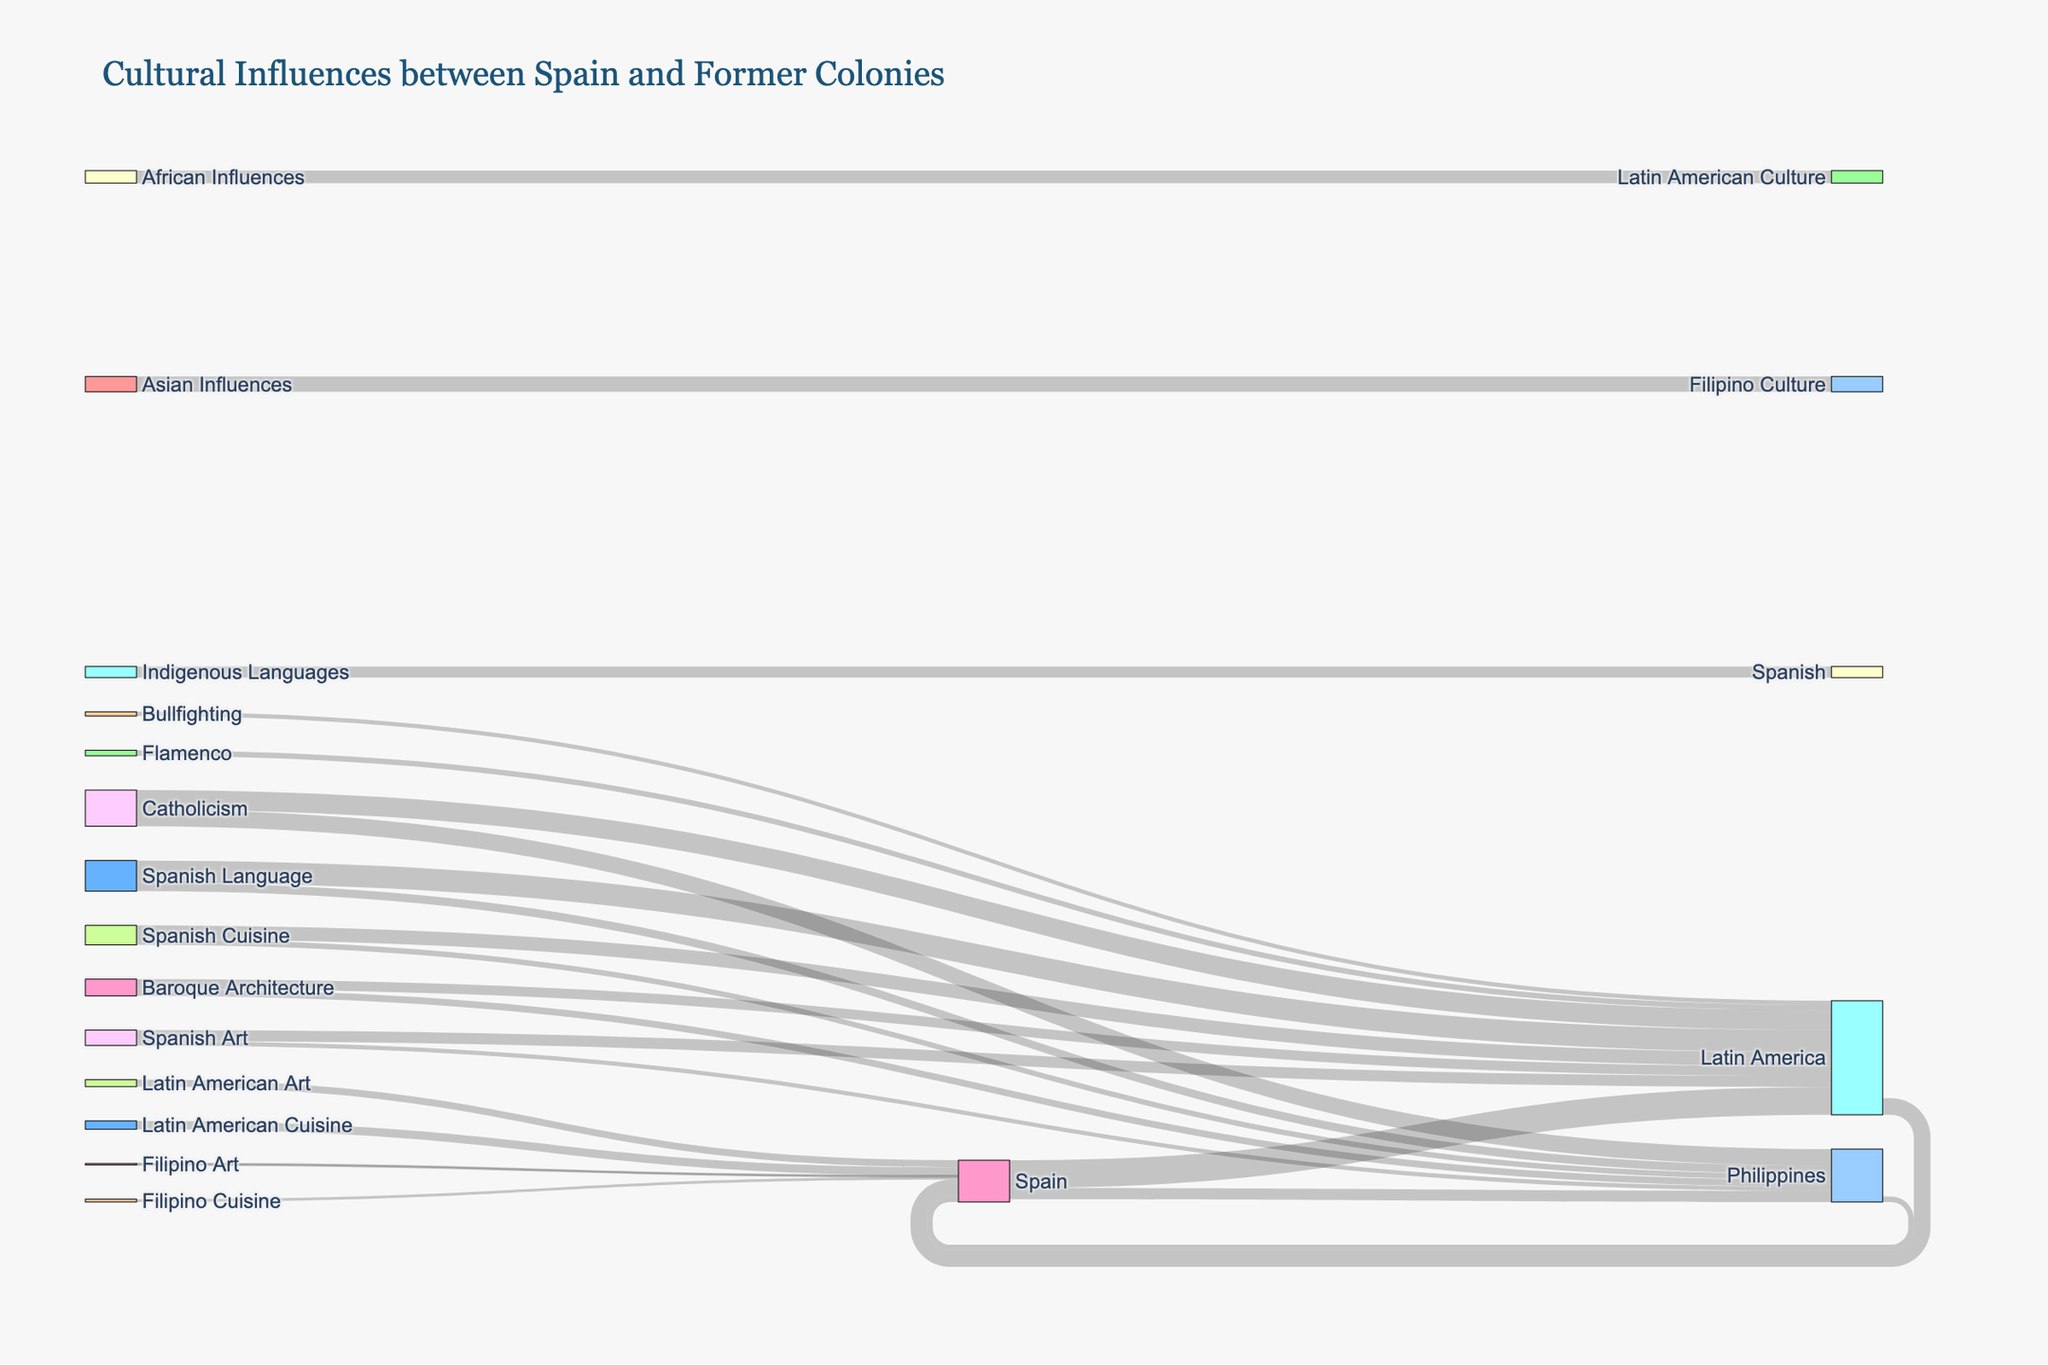What is the title of the diagram? The title of the diagram is typically displayed at the top of the figure, and it provides a summary of what the diagram is about.
Answer: Cultural Influences between Spain and Former Colonies How much influence has Spanish cuisine had on Latin America according to the diagram? To determine the influence of Spanish cuisine on Latin America, look at the link labeled "Spanish Cuisine → Latin America" and refer to the value associated with it.
Answer: 50 Which domain of cultural influence has the highest value from Spain to Latin America? Look for the links originating from Spain to Latin America and identify the domain with the highest value attached. The domains are Spanish Language, Spanish Cuisine, and Spanish Art.
Answer: Spanish Language What is the combined flow value from Spain to the Philippines? Sum the values of all links originating from Spain and targeting the Philippines.
Answer: 40 + 30 + 20 + 15 = 105 How does the value of Catholicism influence in the Philippines compare to its value in Latin America? Look for the values associated with Catholicism for both Latin America and the Philippines and compare them.
Answer: 60 (Philippines) is less than 70 (Latin America) Which region has the highest value of indigenous languages influencing Spanish culture? Locate the link indicating indigenous languages influencing Spanish, and note the region associated with it and its value.
Answer: Latin America What is the value of Baroque Architecture's influence on the Philippines compared to its influence on Latin America? Find the links for Baroque Architecture targeting both the Philippines and Latin America and compare the values.
Answer: 25 (Philippines) is less than 35 (Latin America) If we combine the influence of Flamenco and Bullfighting on Latin America, what is the total value? Add the values of the links labeled Flamenco → Latin America and Bullfighting → Latin America.
Answer: 20 + 15 = 35 Which type of cuisine has a greater influence on Spanish culture, Latin American or Filipino, and by how much? Compare the values of Latin American Cuisine influencing Spain and Filipino Cuisine influencing Spain, and calculate the difference.
Answer: Latin American Cuisine by 20 What are the four main categories of cultural influences depicted in the diagram? Identify the distinct domains of cultural influences, including language, cuisine, art, and religion/architecture as seen in the diagram.
Answer: Language, Cuisine, Art, Religion/Architecture 